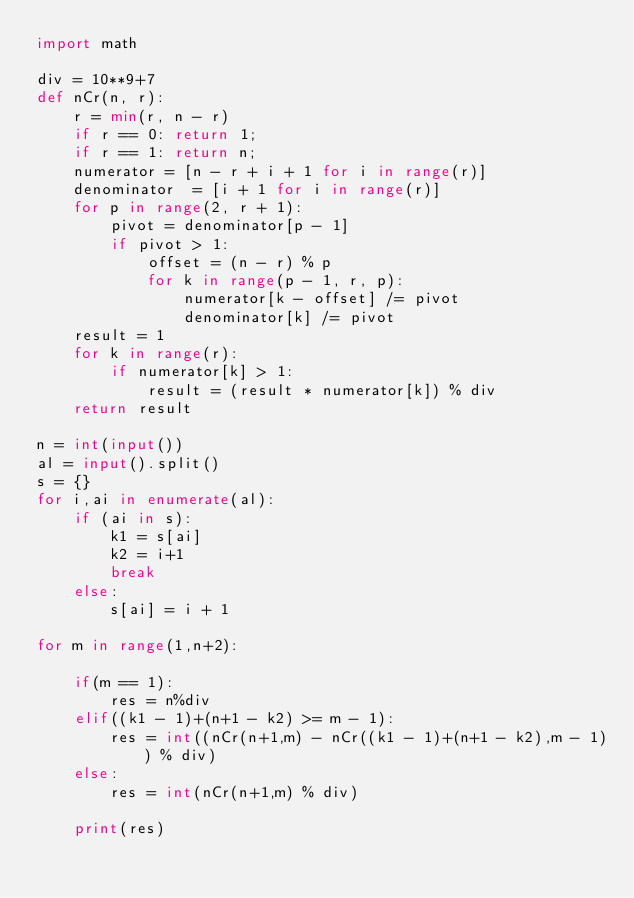Convert code to text. <code><loc_0><loc_0><loc_500><loc_500><_Python_>import math

div = 10**9+7 
def nCr(n, r):
    r = min(r, n - r)
    if r == 0: return 1;
    if r == 1: return n;
    numerator = [n - r + i + 1 for i in range(r)]
    denominator  = [i + 1 for i in range(r)]
    for p in range(2, r + 1):
        pivot = denominator[p - 1]
        if pivot > 1:
            offset = (n - r) % p
            for k in range(p - 1, r, p):
                numerator[k - offset] /= pivot
                denominator[k] /= pivot
    result = 1
    for k in range(r):
        if numerator[k] > 1: 
            result = (result * numerator[k]) % div
    return result

n = int(input())
al = input().split()
s = {}
for i,ai in enumerate(al):
    if (ai in s):
        k1 = s[ai]
        k2 = i+1
        break
    else:
        s[ai] = i + 1

for m in range(1,n+2):
    
    if(m == 1):
        res = n%div
    elif((k1 - 1)+(n+1 - k2) >= m - 1):
        res = int((nCr(n+1,m) - nCr((k1 - 1)+(n+1 - k2),m - 1)) % div)
    else:
        res = int(nCr(n+1,m) % div)
    
    print(res)
    </code> 